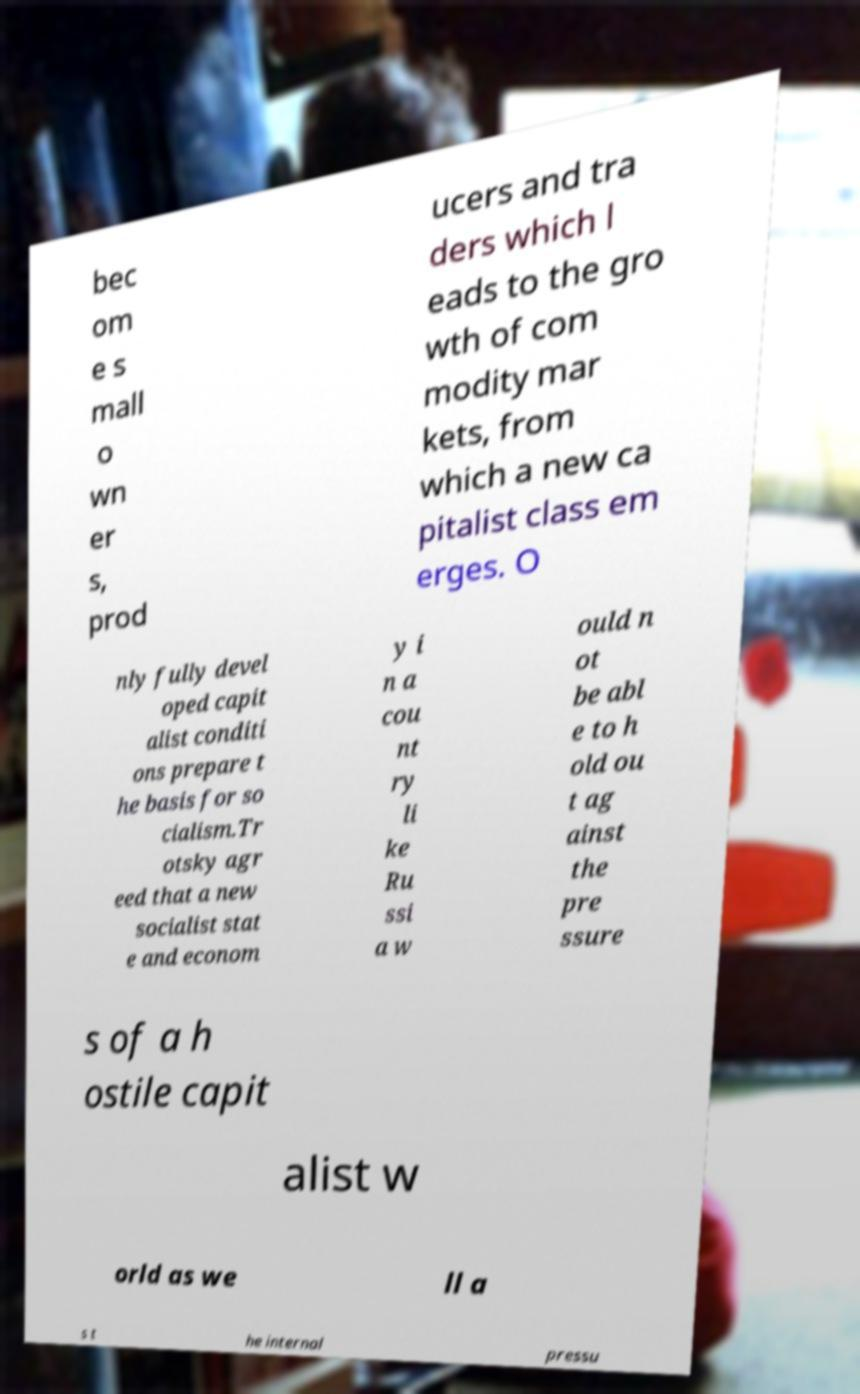Could you extract and type out the text from this image? bec om e s mall o wn er s, prod ucers and tra ders which l eads to the gro wth of com modity mar kets, from which a new ca pitalist class em erges. O nly fully devel oped capit alist conditi ons prepare t he basis for so cialism.Tr otsky agr eed that a new socialist stat e and econom y i n a cou nt ry li ke Ru ssi a w ould n ot be abl e to h old ou t ag ainst the pre ssure s of a h ostile capit alist w orld as we ll a s t he internal pressu 